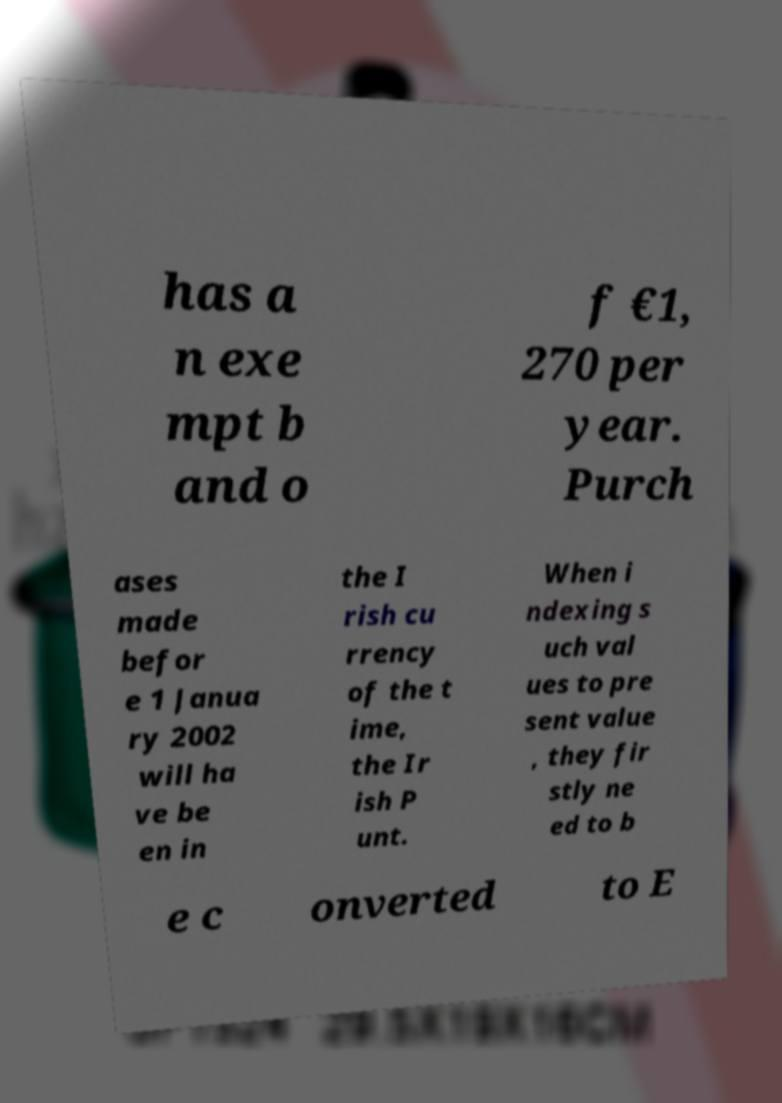For documentation purposes, I need the text within this image transcribed. Could you provide that? has a n exe mpt b and o f €1, 270 per year. Purch ases made befor e 1 Janua ry 2002 will ha ve be en in the I rish cu rrency of the t ime, the Ir ish P unt. When i ndexing s uch val ues to pre sent value , they fir stly ne ed to b e c onverted to E 